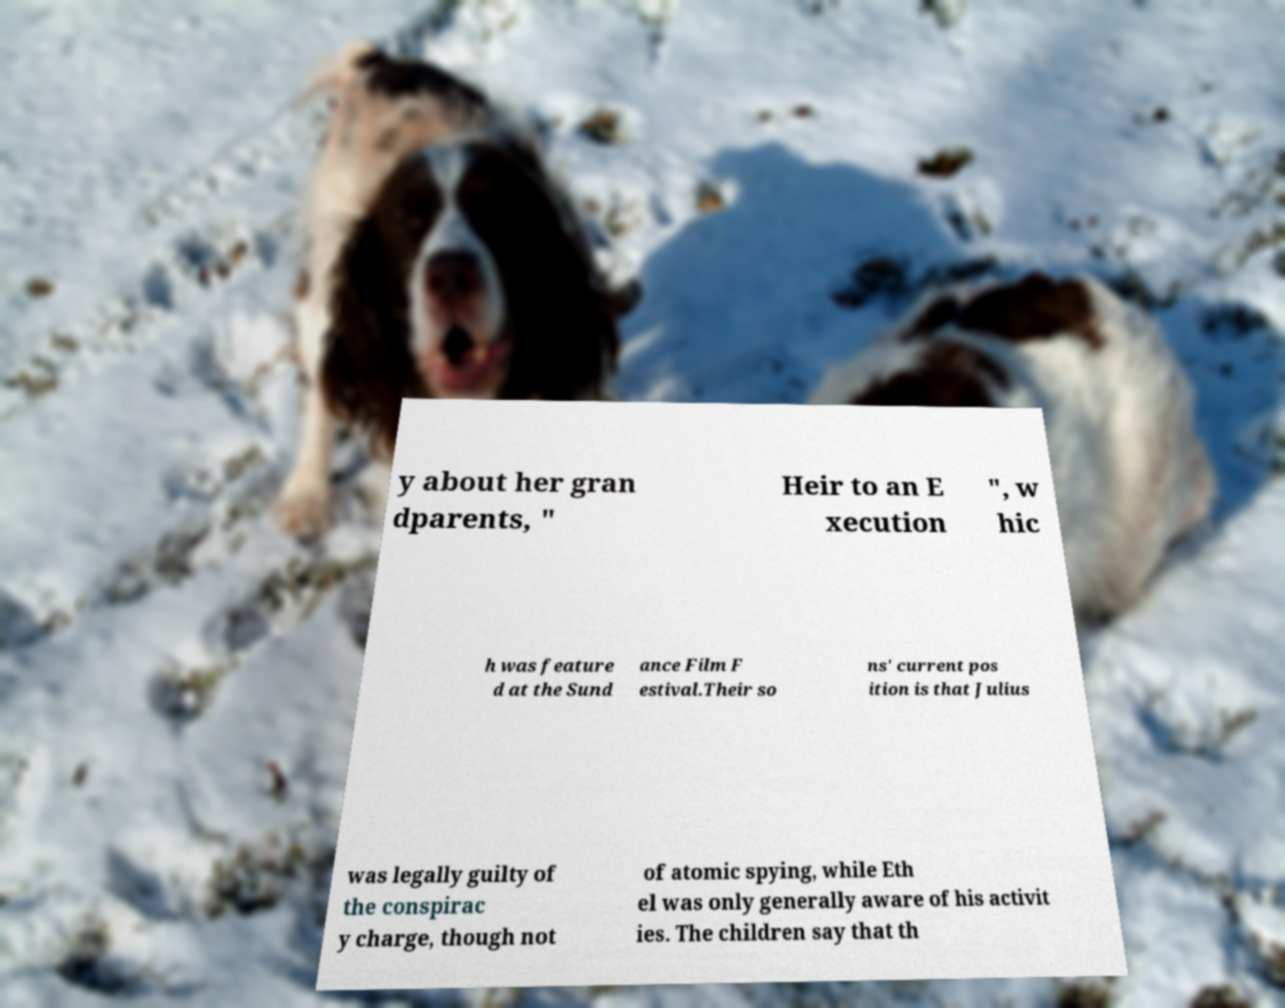Could you extract and type out the text from this image? y about her gran dparents, " Heir to an E xecution ", w hic h was feature d at the Sund ance Film F estival.Their so ns' current pos ition is that Julius was legally guilty of the conspirac y charge, though not of atomic spying, while Eth el was only generally aware of his activit ies. The children say that th 